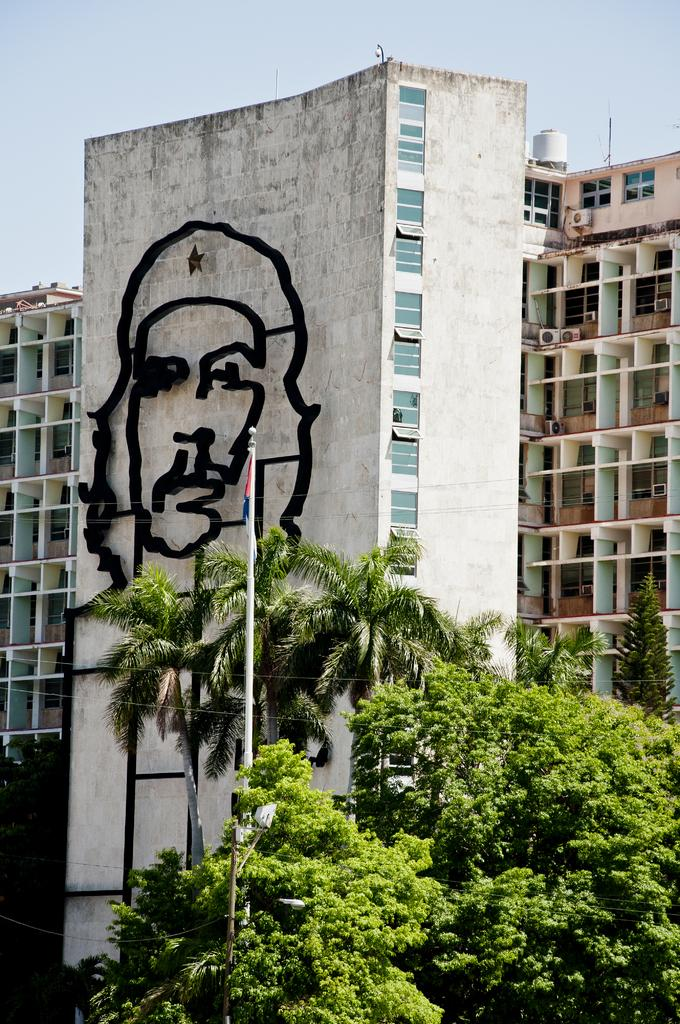What is located in the center of the image? There are buildings in the center of the image. What can be seen attached to the pole in the image? There is a flag on the pole. What type of vegetation is present in the image? There are trees in the image. What is visible at the top of the image? The sky is visible at the top of the image. What type of power can be seen flowing through the trees in the image? There is no power or electricity visible in the image; it only features buildings, a pole with a flag, trees, and the sky. What type of destruction can be seen in the image? There is no destruction or damage visible in the image; it appears to be a peaceful scene with buildings, a pole with a flag, trees, and the sky. 